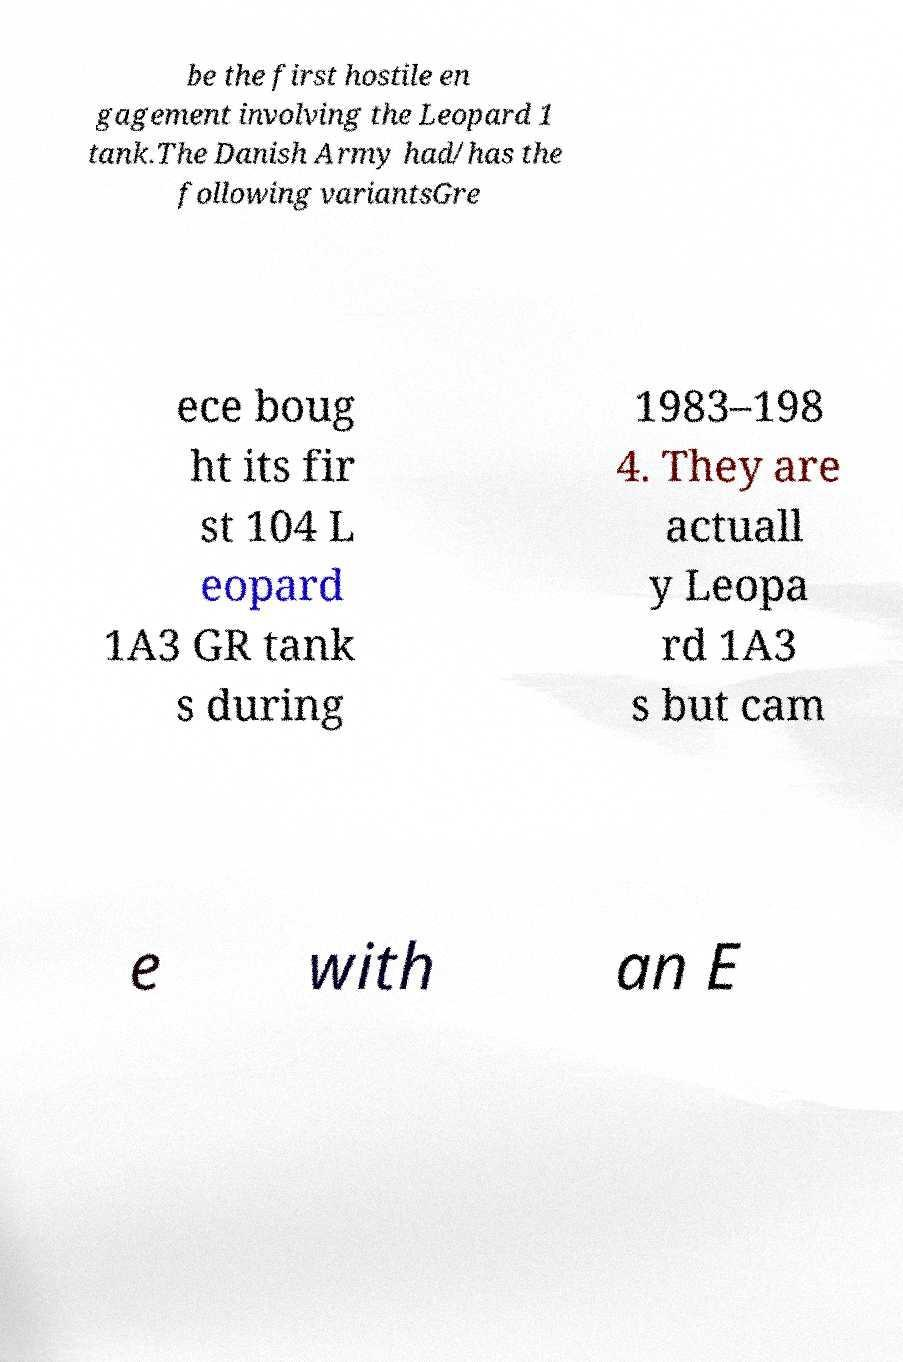What messages or text are displayed in this image? I need them in a readable, typed format. be the first hostile en gagement involving the Leopard 1 tank.The Danish Army had/has the following variantsGre ece boug ht its fir st 104 L eopard 1A3 GR tank s during 1983–198 4. They are actuall y Leopa rd 1A3 s but cam e with an E 